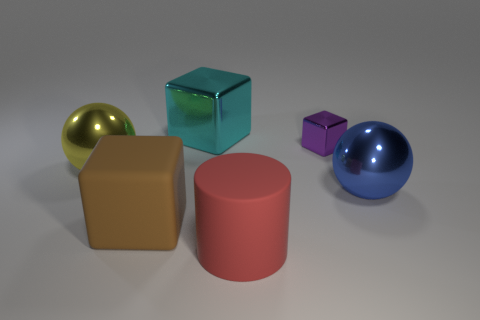Is the color of the ball that is to the right of the tiny metallic thing the same as the large ball left of the big cyan thing?
Your response must be concise. No. There is a object in front of the large brown rubber cube; is its size the same as the ball that is behind the blue sphere?
Your answer should be very brief. Yes. Is there any other thing that is the same material as the cyan thing?
Offer a terse response. Yes. What is the material of the sphere that is right of the cube that is in front of the big sphere on the left side of the rubber block?
Give a very brief answer. Metal. Is the shape of the red thing the same as the large brown thing?
Your answer should be very brief. No. There is another large object that is the same shape as the blue metal thing; what is its material?
Provide a succinct answer. Metal. There is a purple cube that is made of the same material as the big cyan block; what size is it?
Ensure brevity in your answer.  Small. How many cyan things are large matte cylinders or metallic balls?
Offer a terse response. 0. How many large brown rubber cubes are on the right side of the big sphere that is to the left of the big blue object?
Make the answer very short. 1. Are there more big yellow shiny balls behind the purple thing than large brown blocks that are in front of the yellow thing?
Your answer should be compact. No. 